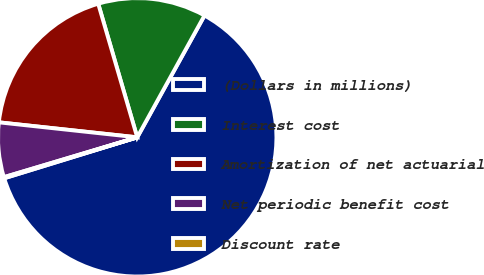Convert chart. <chart><loc_0><loc_0><loc_500><loc_500><pie_chart><fcel>(Dollars in millions)<fcel>Interest cost<fcel>Amortization of net actuarial<fcel>Net periodic benefit cost<fcel>Discount rate<nl><fcel>62.22%<fcel>12.55%<fcel>18.76%<fcel>6.34%<fcel>0.13%<nl></chart> 